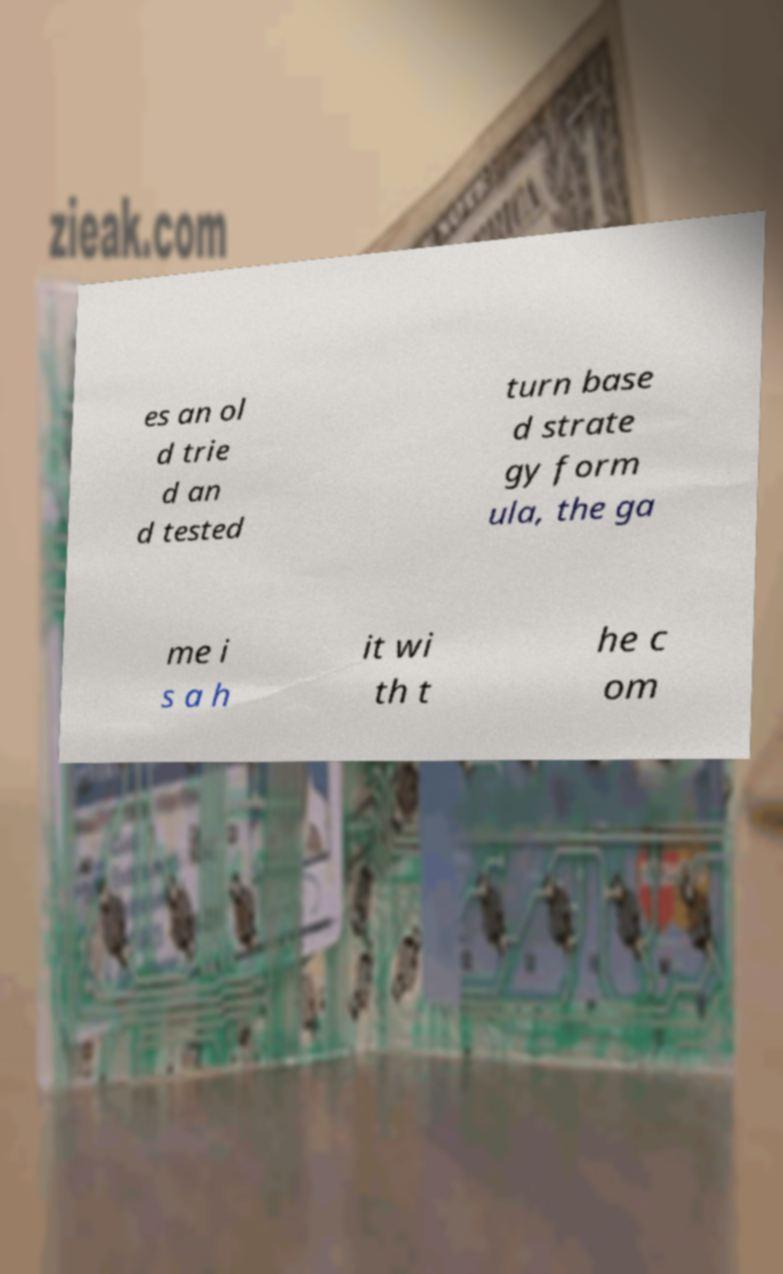Can you read and provide the text displayed in the image?This photo seems to have some interesting text. Can you extract and type it out for me? es an ol d trie d an d tested turn base d strate gy form ula, the ga me i s a h it wi th t he c om 